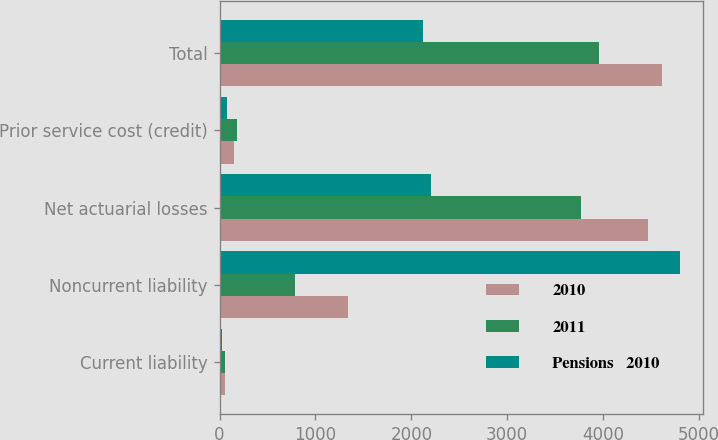Convert chart. <chart><loc_0><loc_0><loc_500><loc_500><stacked_bar_chart><ecel><fcel>Current liability<fcel>Noncurrent liability<fcel>Net actuarial losses<fcel>Prior service cost (credit)<fcel>Total<nl><fcel>2010<fcel>60<fcel>1343<fcel>4473<fcel>147<fcel>4620<nl><fcel>2011<fcel>55<fcel>785<fcel>3774<fcel>184<fcel>3958<nl><fcel>Pensions   2010<fcel>27<fcel>4803<fcel>2206<fcel>80<fcel>2126<nl></chart> 